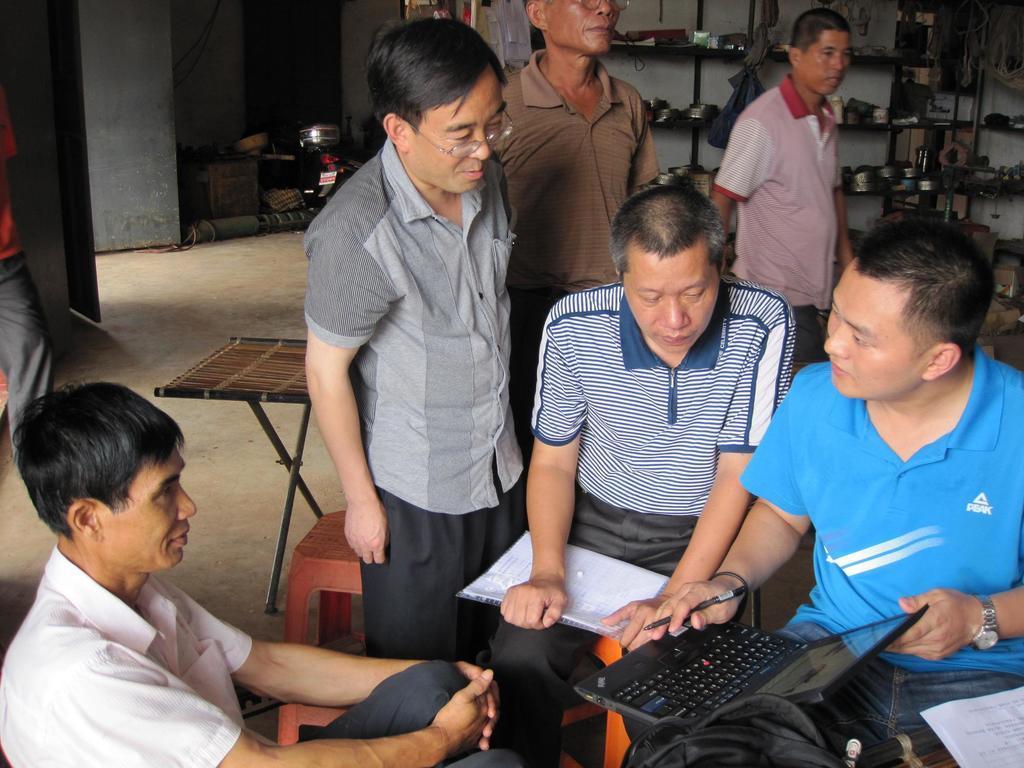Can you describe this image briefly? In this image, there are a few people. Among them, we can see a person sitting is holding a device. We can also see some objects on the bottom left. We can see a stool and the stand. We can see the wall. We can see some shelves with objects. We can also see the ground with some objects. 